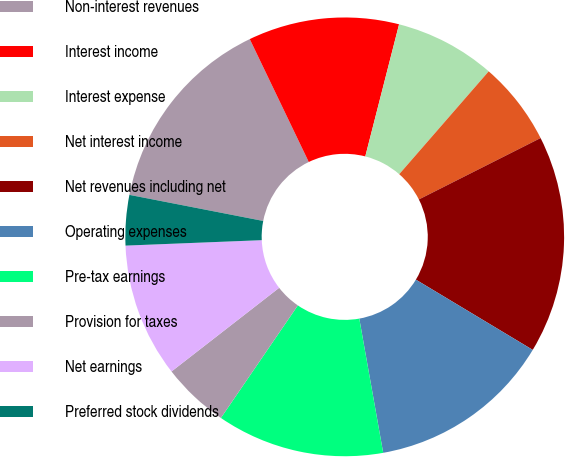Convert chart to OTSL. <chart><loc_0><loc_0><loc_500><loc_500><pie_chart><fcel>Non-interest revenues<fcel>Interest income<fcel>Interest expense<fcel>Net interest income<fcel>Net revenues including net<fcel>Operating expenses<fcel>Pre-tax earnings<fcel>Provision for taxes<fcel>Net earnings<fcel>Preferred stock dividends<nl><fcel>14.81%<fcel>11.11%<fcel>7.41%<fcel>6.17%<fcel>16.05%<fcel>13.58%<fcel>12.35%<fcel>4.94%<fcel>9.88%<fcel>3.7%<nl></chart> 